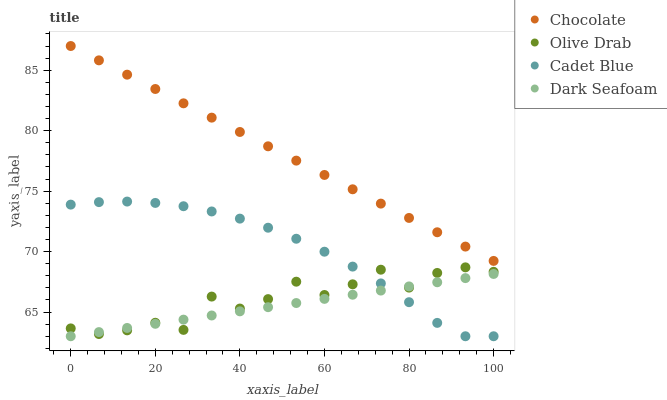Does Dark Seafoam have the minimum area under the curve?
Answer yes or no. Yes. Does Chocolate have the maximum area under the curve?
Answer yes or no. Yes. Does Cadet Blue have the minimum area under the curve?
Answer yes or no. No. Does Cadet Blue have the maximum area under the curve?
Answer yes or no. No. Is Chocolate the smoothest?
Answer yes or no. Yes. Is Olive Drab the roughest?
Answer yes or no. Yes. Is Cadet Blue the smoothest?
Answer yes or no. No. Is Cadet Blue the roughest?
Answer yes or no. No. Does Dark Seafoam have the lowest value?
Answer yes or no. Yes. Does Olive Drab have the lowest value?
Answer yes or no. No. Does Chocolate have the highest value?
Answer yes or no. Yes. Does Cadet Blue have the highest value?
Answer yes or no. No. Is Dark Seafoam less than Chocolate?
Answer yes or no. Yes. Is Chocolate greater than Olive Drab?
Answer yes or no. Yes. Does Cadet Blue intersect Dark Seafoam?
Answer yes or no. Yes. Is Cadet Blue less than Dark Seafoam?
Answer yes or no. No. Is Cadet Blue greater than Dark Seafoam?
Answer yes or no. No. Does Dark Seafoam intersect Chocolate?
Answer yes or no. No. 